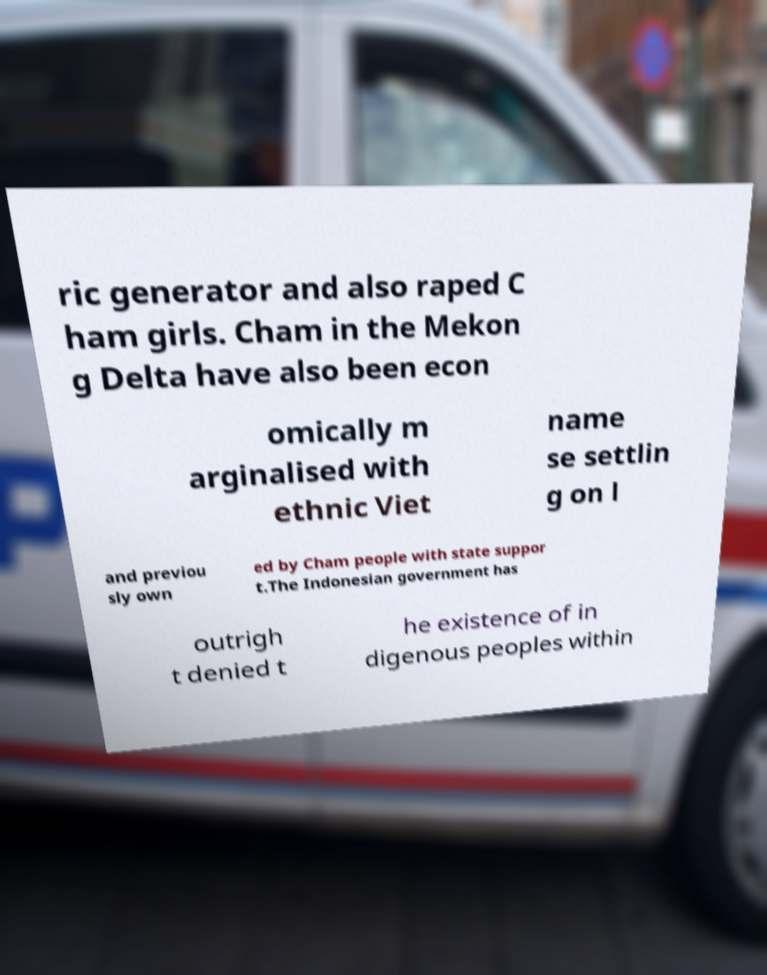For documentation purposes, I need the text within this image transcribed. Could you provide that? ric generator and also raped C ham girls. Cham in the Mekon g Delta have also been econ omically m arginalised with ethnic Viet name se settlin g on l and previou sly own ed by Cham people with state suppor t.The Indonesian government has outrigh t denied t he existence of in digenous peoples within 